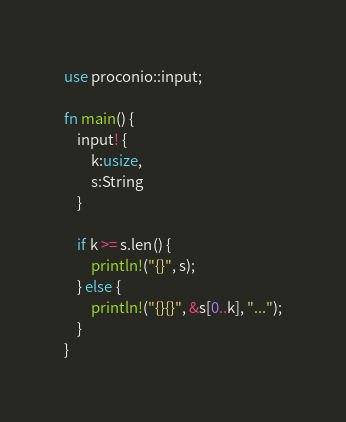Convert code to text. <code><loc_0><loc_0><loc_500><loc_500><_Rust_>use proconio::input;

fn main() {
    input! {
        k:usize,
        s:String
    }

    if k >= s.len() {
        println!("{}", s);
    } else {
        println!("{}{}", &s[0..k], "...");
    }
}
</code> 